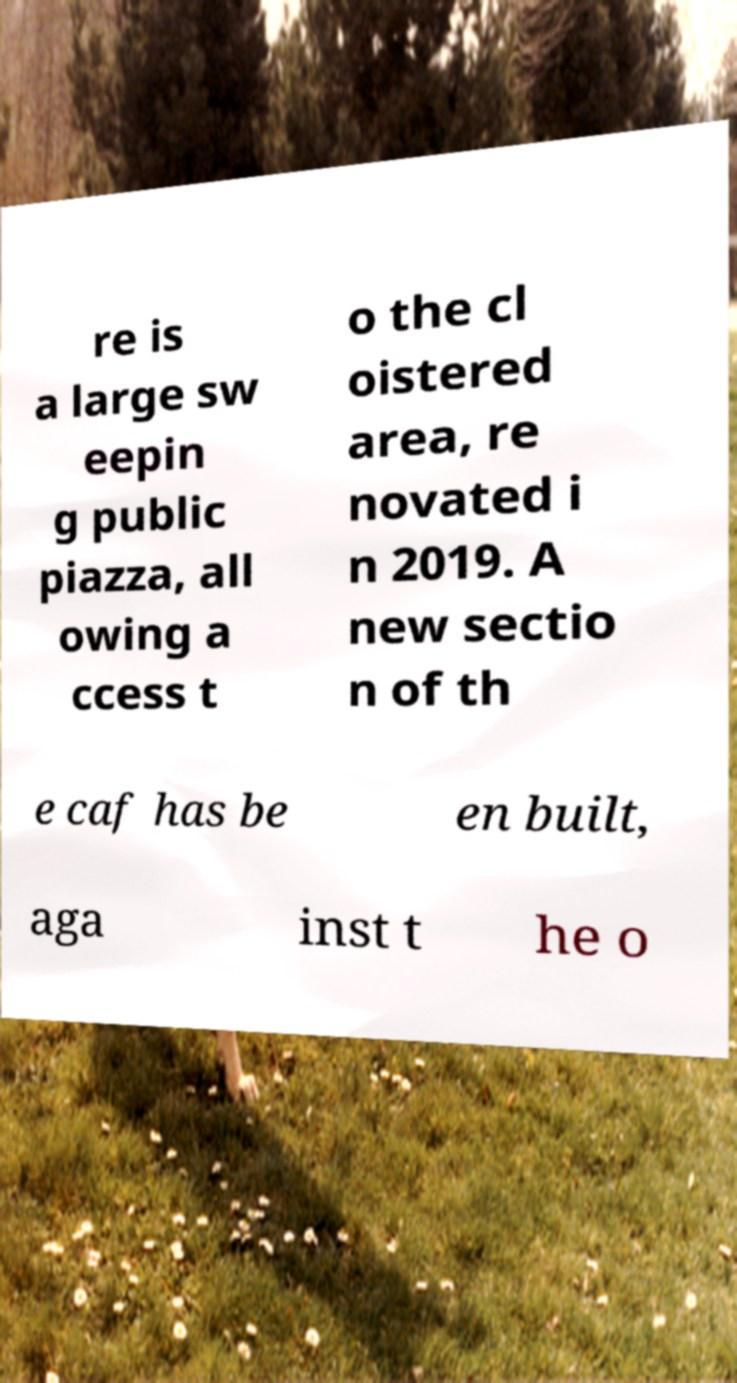I need the written content from this picture converted into text. Can you do that? re is a large sw eepin g public piazza, all owing a ccess t o the cl oistered area, re novated i n 2019. A new sectio n of th e caf has be en built, aga inst t he o 